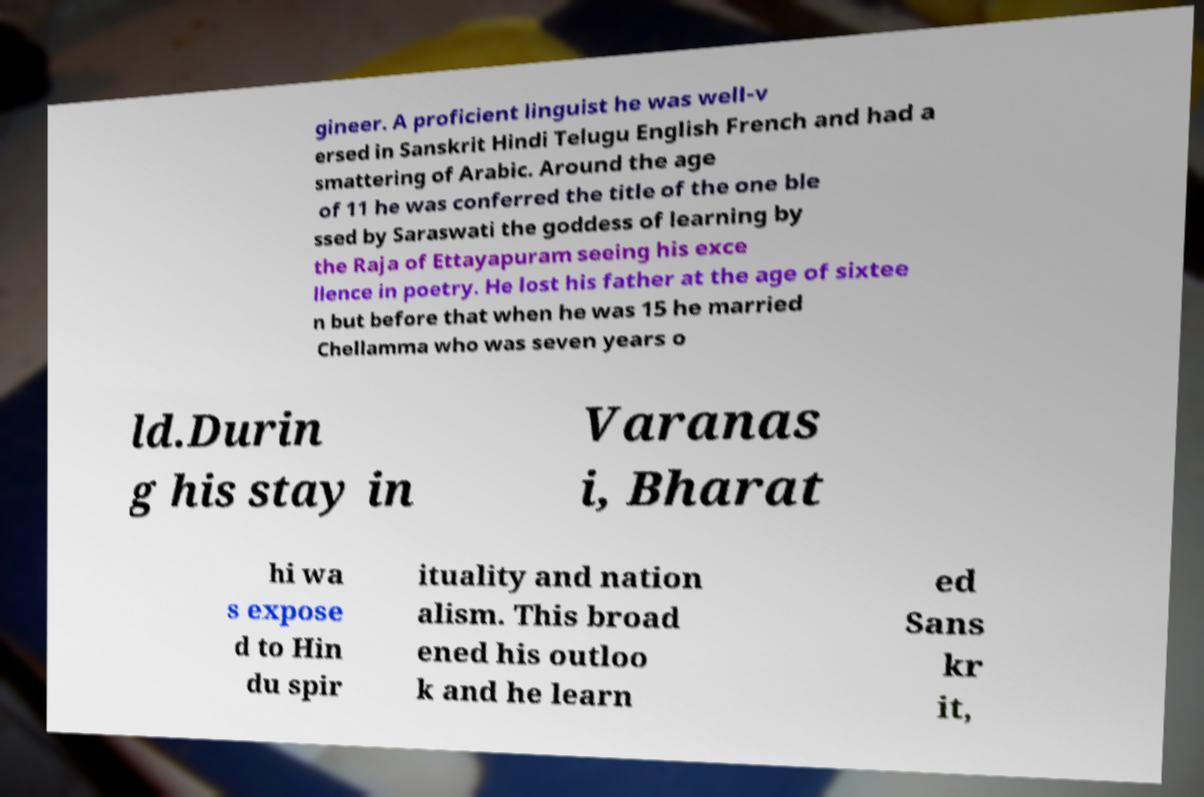Please read and relay the text visible in this image. What does it say? gineer. A proficient linguist he was well-v ersed in Sanskrit Hindi Telugu English French and had a smattering of Arabic. Around the age of 11 he was conferred the title of the one ble ssed by Saraswati the goddess of learning by the Raja of Ettayapuram seeing his exce llence in poetry. He lost his father at the age of sixtee n but before that when he was 15 he married Chellamma who was seven years o ld.Durin g his stay in Varanas i, Bharat hi wa s expose d to Hin du spir ituality and nation alism. This broad ened his outloo k and he learn ed Sans kr it, 